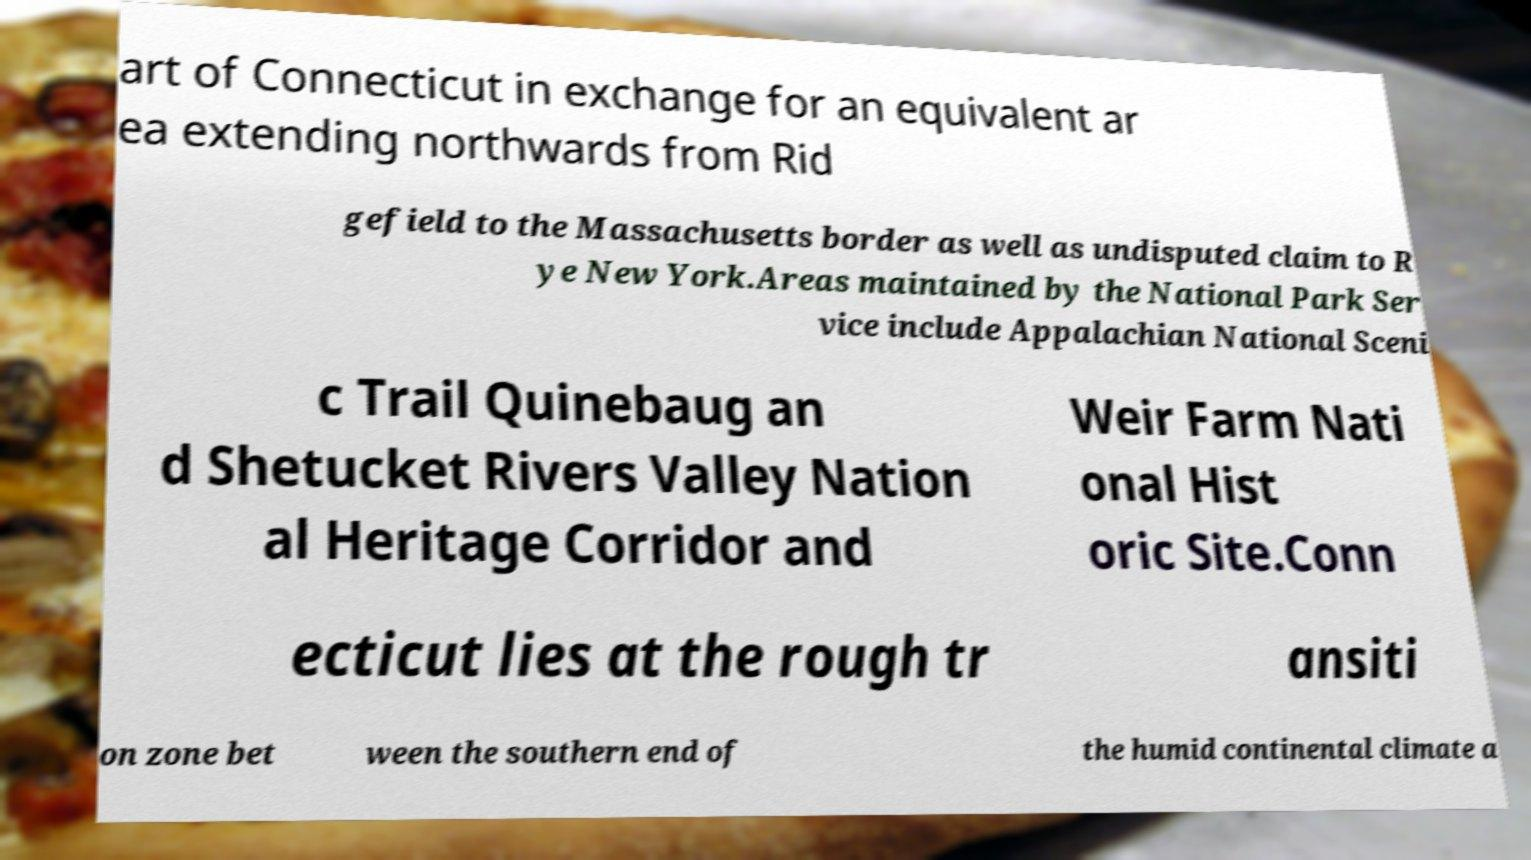Can you read and provide the text displayed in the image?This photo seems to have some interesting text. Can you extract and type it out for me? art of Connecticut in exchange for an equivalent ar ea extending northwards from Rid gefield to the Massachusetts border as well as undisputed claim to R ye New York.Areas maintained by the National Park Ser vice include Appalachian National Sceni c Trail Quinebaug an d Shetucket Rivers Valley Nation al Heritage Corridor and Weir Farm Nati onal Hist oric Site.Conn ecticut lies at the rough tr ansiti on zone bet ween the southern end of the humid continental climate a 